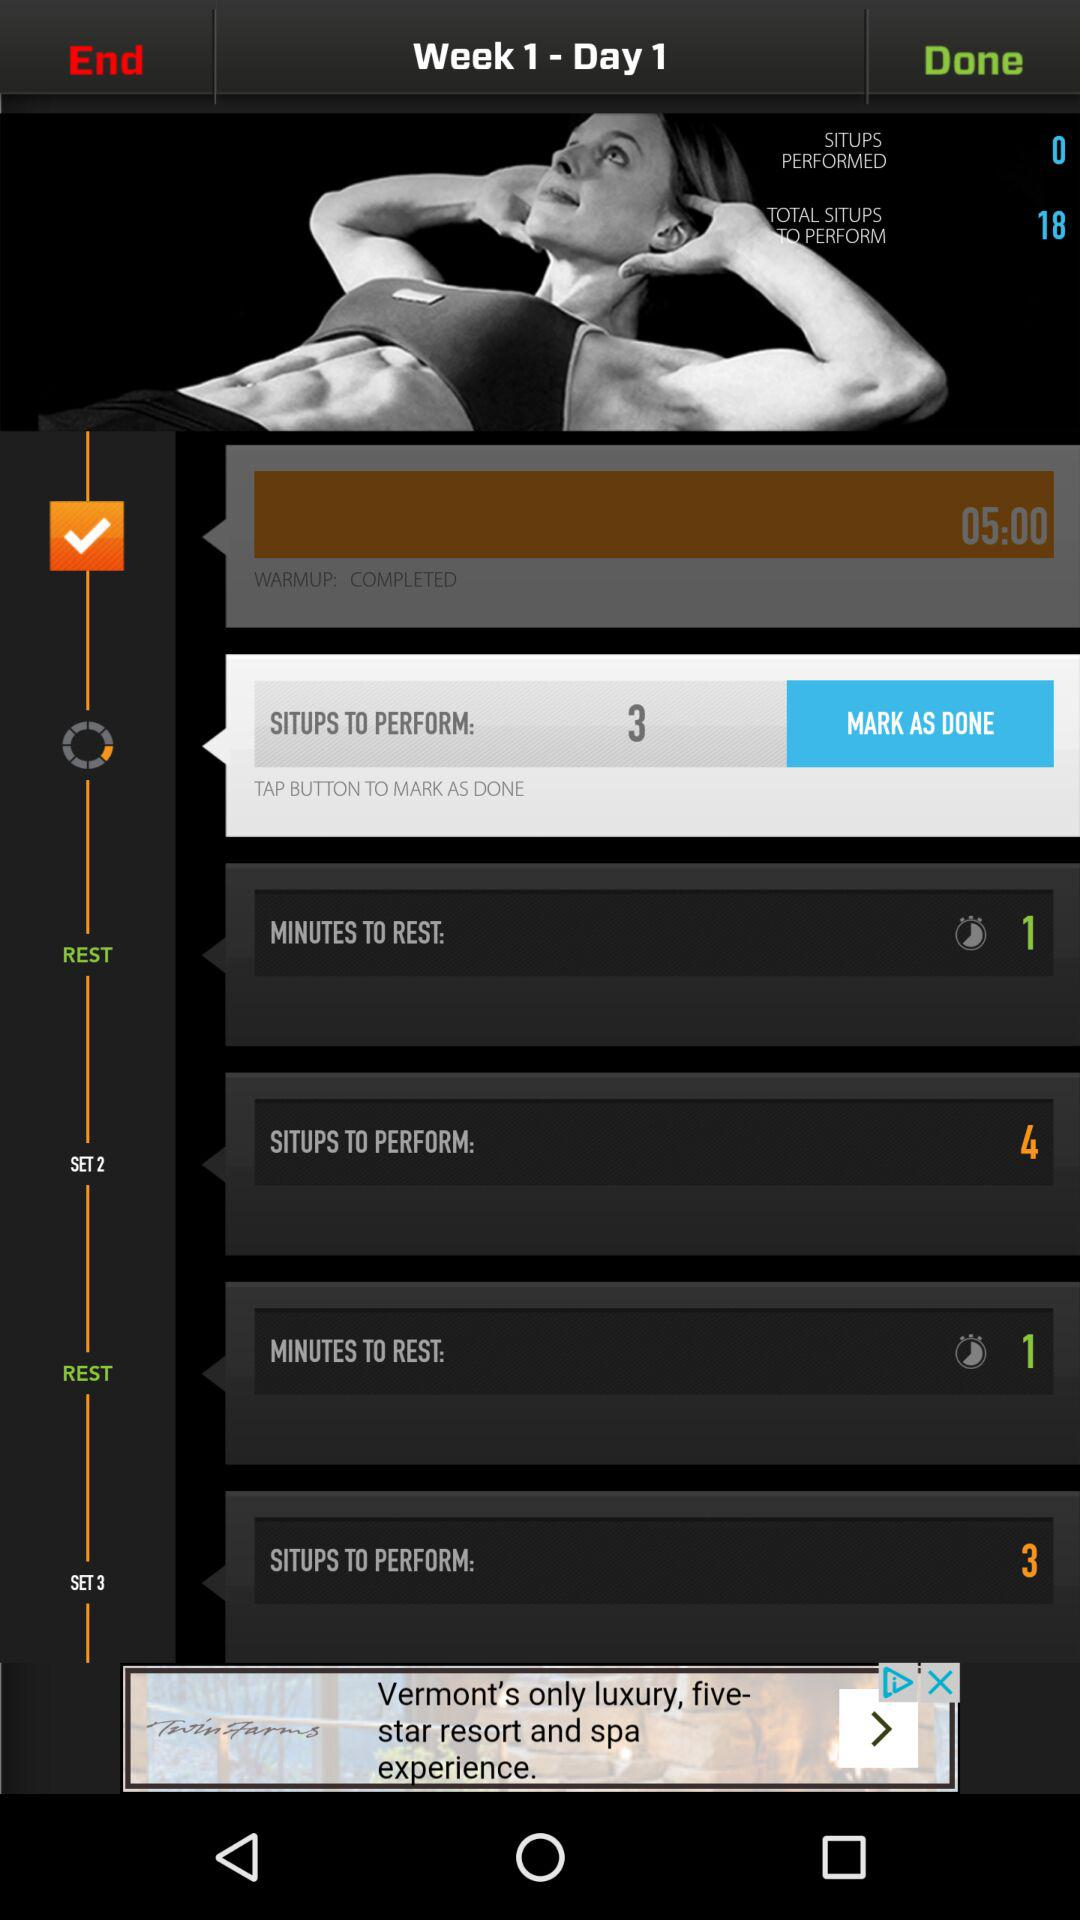What is the time duration of rest? The time duration of rest is 1 minute. 